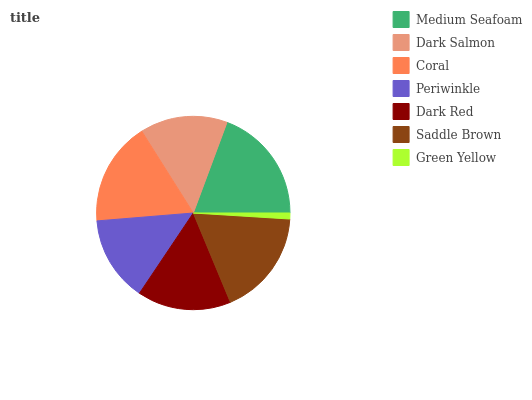Is Green Yellow the minimum?
Answer yes or no. Yes. Is Medium Seafoam the maximum?
Answer yes or no. Yes. Is Dark Salmon the minimum?
Answer yes or no. No. Is Dark Salmon the maximum?
Answer yes or no. No. Is Medium Seafoam greater than Dark Salmon?
Answer yes or no. Yes. Is Dark Salmon less than Medium Seafoam?
Answer yes or no. Yes. Is Dark Salmon greater than Medium Seafoam?
Answer yes or no. No. Is Medium Seafoam less than Dark Salmon?
Answer yes or no. No. Is Dark Red the high median?
Answer yes or no. Yes. Is Dark Red the low median?
Answer yes or no. Yes. Is Coral the high median?
Answer yes or no. No. Is Coral the low median?
Answer yes or no. No. 